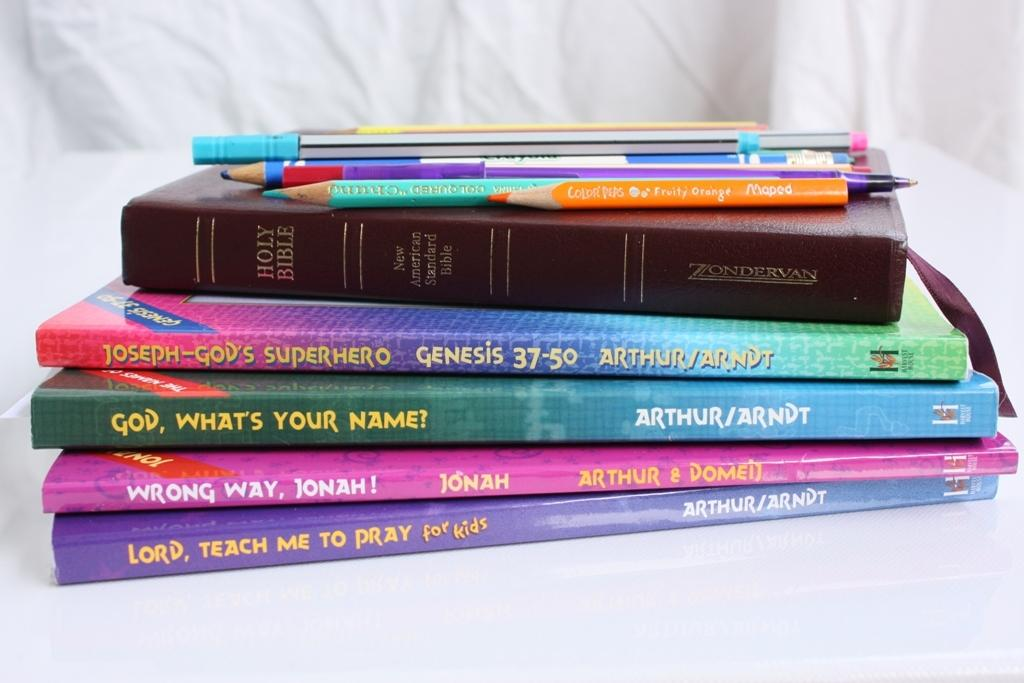<image>
Present a compact description of the photo's key features. A book titled God What's Your Name? is sitting in the middle of other religious books 